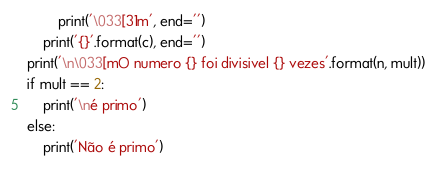<code> <loc_0><loc_0><loc_500><loc_500><_Python_>        print('\033[31m', end='')
    print('{}'.format(c), end='')
print('\n\033[mO numero {} foi divisivel {} vezes'.format(n, mult))
if mult == 2:
    print('\né primo')
else:
    print('Não é primo')
</code> 